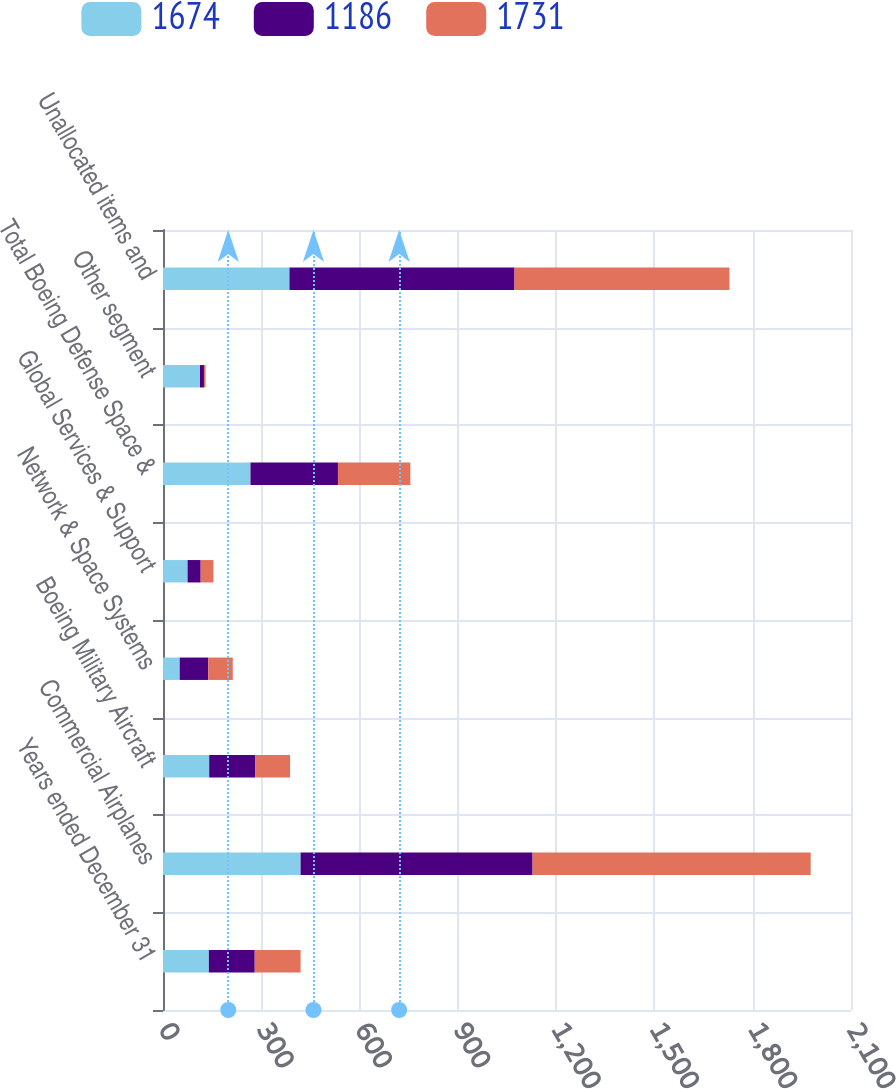Convert chart to OTSL. <chart><loc_0><loc_0><loc_500><loc_500><stacked_bar_chart><ecel><fcel>Years ended December 31<fcel>Commercial Airplanes<fcel>Boeing Military Aircraft<fcel>Network & Space Systems<fcel>Global Services & Support<fcel>Total Boeing Defense Space &<fcel>Other segment<fcel>Unallocated items and<nl><fcel>1674<fcel>140<fcel>420<fcel>141<fcel>51<fcel>75<fcel>267<fcel>113<fcel>386<nl><fcel>1186<fcel>140<fcel>708<fcel>140<fcel>87<fcel>40<fcel>267<fcel>12<fcel>687<nl><fcel>1731<fcel>140<fcel>849<fcel>107<fcel>75<fcel>39<fcel>221<fcel>5<fcel>656<nl></chart> 